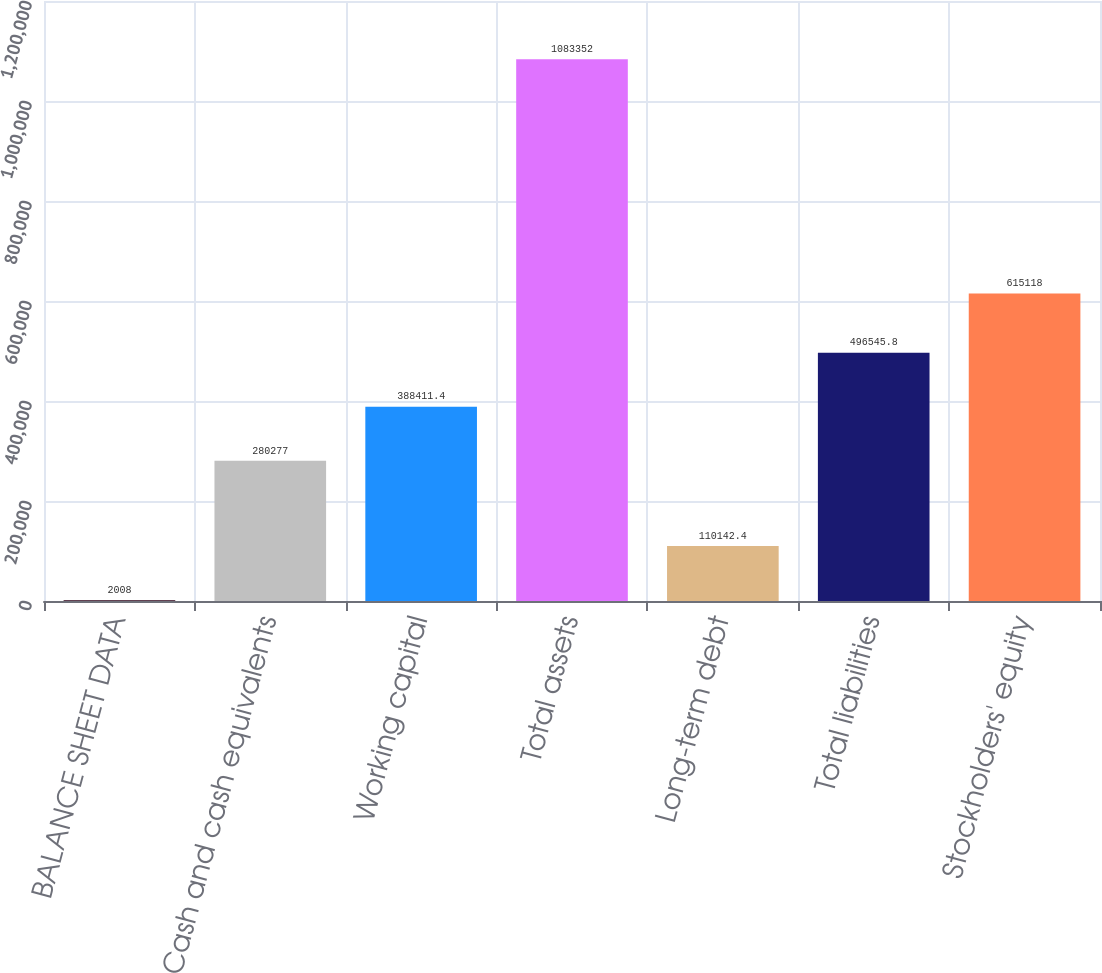Convert chart to OTSL. <chart><loc_0><loc_0><loc_500><loc_500><bar_chart><fcel>BALANCE SHEET DATA<fcel>Cash and cash equivalents<fcel>Working capital<fcel>Total assets<fcel>Long-term debt<fcel>Total liabilities<fcel>Stockholders' equity<nl><fcel>2008<fcel>280277<fcel>388411<fcel>1.08335e+06<fcel>110142<fcel>496546<fcel>615118<nl></chart> 